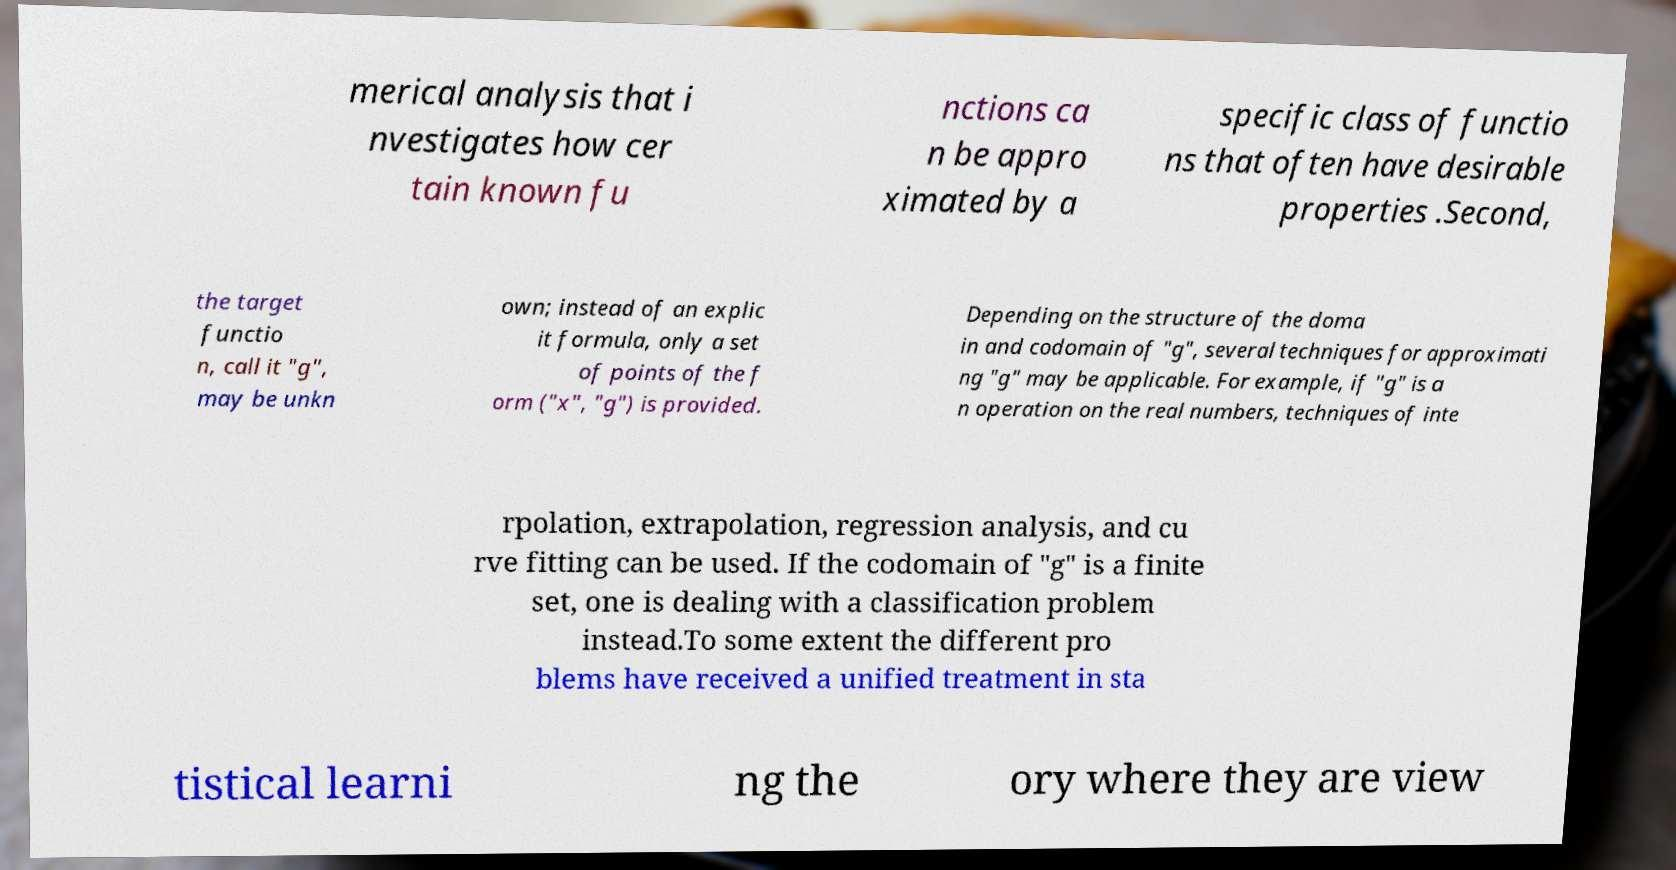Please read and relay the text visible in this image. What does it say? merical analysis that i nvestigates how cer tain known fu nctions ca n be appro ximated by a specific class of functio ns that often have desirable properties .Second, the target functio n, call it "g", may be unkn own; instead of an explic it formula, only a set of points of the f orm ("x", "g") is provided. Depending on the structure of the doma in and codomain of "g", several techniques for approximati ng "g" may be applicable. For example, if "g" is a n operation on the real numbers, techniques of inte rpolation, extrapolation, regression analysis, and cu rve fitting can be used. If the codomain of "g" is a finite set, one is dealing with a classification problem instead.To some extent the different pro blems have received a unified treatment in sta tistical learni ng the ory where they are view 